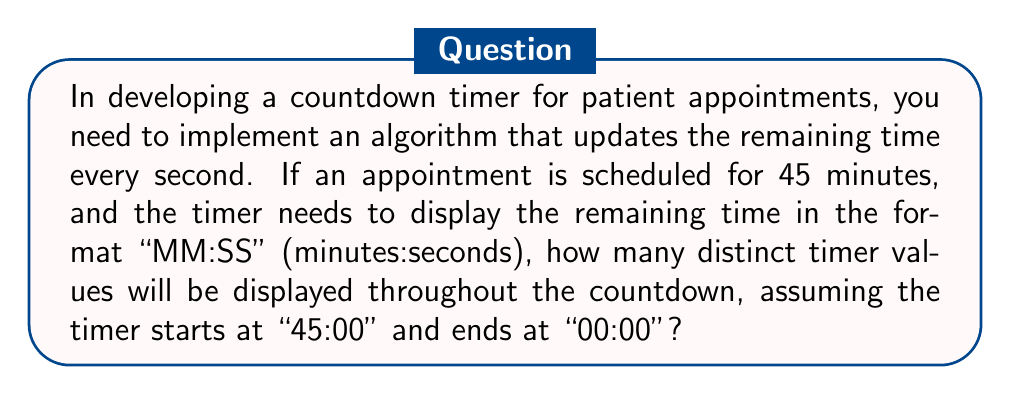Can you answer this question? To solve this problem, let's break it down into steps:

1) First, we need to calculate the total number of seconds in 45 minutes:
   $45 \text{ minutes} \times 60 \text{ seconds/minute} = 2700 \text{ seconds}$

2) The timer will update every second, starting from 2700 seconds (45:00) down to 0 seconds (00:00). This means there are 2701 total seconds to display (including 0).

3) However, not all of these will be distinct displays. The timer format "MM:SS" will only change when either the minutes or seconds change.

4) The seconds will cycle through 60 distinct values (00 to 59) for each minute, except for the last minute which will only go from 59 to 00.

5) The minutes will decrease from 45 to 0, giving 46 distinct minute values.

6) To calculate the total number of distinct displays, we can use the following formula:

   $$\text{Distinct displays} = (\text{Number of full minutes} \times 60) + \text{Seconds in last minute} + 1$$

   Where the +1 accounts for the final "00:00" display.

7) Plugging in our values:

   $$\text{Distinct displays} = (45 \times 60) + 60 + 1 = 2700 + 60 + 1 = 2761$$

Therefore, there will be 2761 distinct timer values displayed throughout the countdown.
Answer: 2761 distinct timer values 